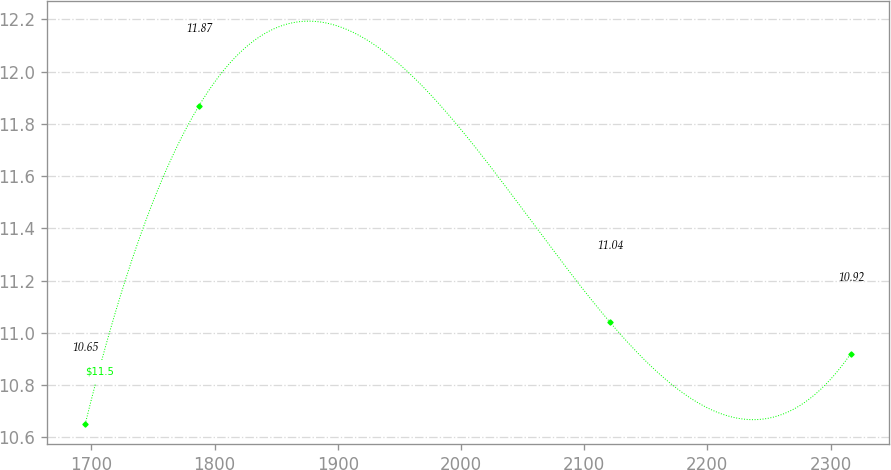Convert chart to OTSL. <chart><loc_0><loc_0><loc_500><loc_500><line_chart><ecel><fcel>$11.5<nl><fcel>1695.04<fcel>10.65<nl><fcel>1787.5<fcel>11.87<nl><fcel>2120.98<fcel>11.04<nl><fcel>2316.41<fcel>10.92<nl></chart> 